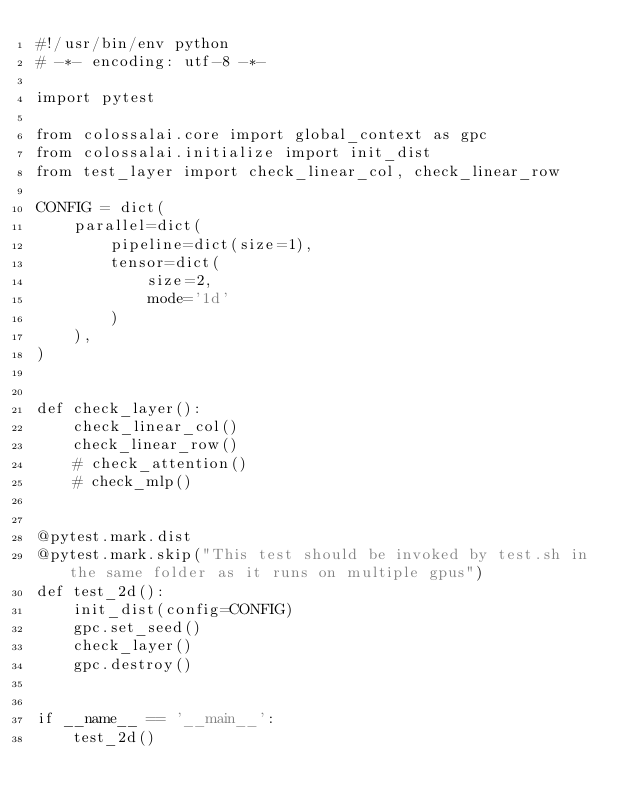Convert code to text. <code><loc_0><loc_0><loc_500><loc_500><_Python_>#!/usr/bin/env python
# -*- encoding: utf-8 -*-

import pytest

from colossalai.core import global_context as gpc
from colossalai.initialize import init_dist
from test_layer import check_linear_col, check_linear_row

CONFIG = dict(
    parallel=dict(
        pipeline=dict(size=1),
        tensor=dict(
            size=2,
            mode='1d'
        )
    ),
)


def check_layer():
    check_linear_col()
    check_linear_row()
    # check_attention()
    # check_mlp()


@pytest.mark.dist
@pytest.mark.skip("This test should be invoked by test.sh in the same folder as it runs on multiple gpus")
def test_2d():
    init_dist(config=CONFIG)
    gpc.set_seed()
    check_layer()
    gpc.destroy()


if __name__ == '__main__':
    test_2d()
</code> 